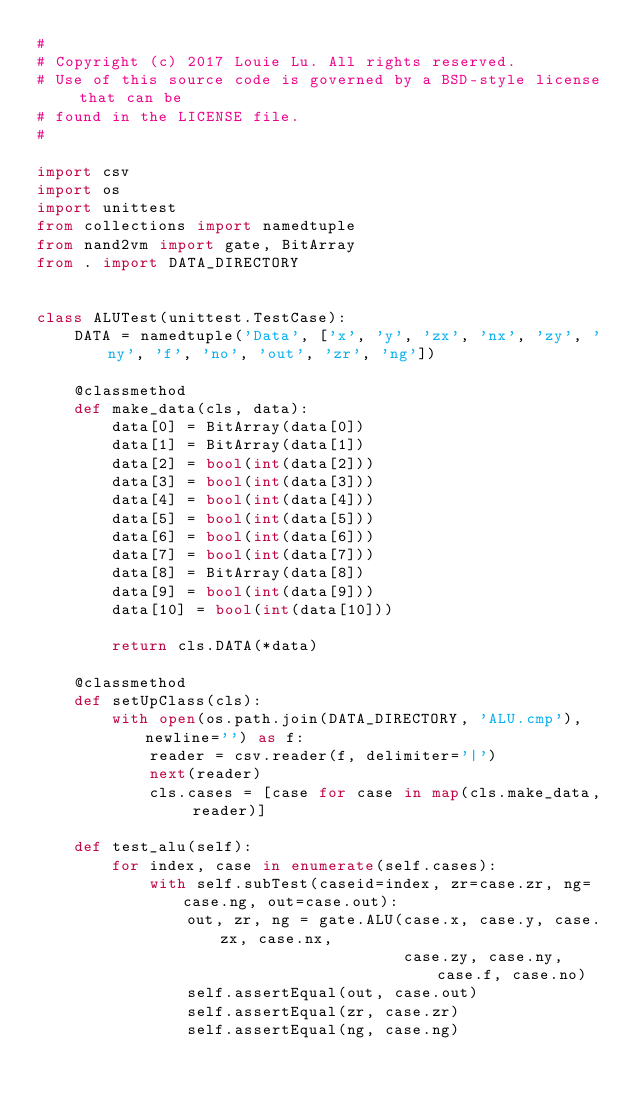<code> <loc_0><loc_0><loc_500><loc_500><_Python_>#
# Copyright (c) 2017 Louie Lu. All rights reserved.
# Use of this source code is governed by a BSD-style license that can be
# found in the LICENSE file.
#

import csv
import os
import unittest
from collections import namedtuple
from nand2vm import gate, BitArray
from . import DATA_DIRECTORY


class ALUTest(unittest.TestCase):
    DATA = namedtuple('Data', ['x', 'y', 'zx', 'nx', 'zy', 'ny', 'f', 'no', 'out', 'zr', 'ng'])

    @classmethod
    def make_data(cls, data):
        data[0] = BitArray(data[0])
        data[1] = BitArray(data[1])
        data[2] = bool(int(data[2]))
        data[3] = bool(int(data[3]))
        data[4] = bool(int(data[4]))
        data[5] = bool(int(data[5]))
        data[6] = bool(int(data[6]))
        data[7] = bool(int(data[7]))
        data[8] = BitArray(data[8])
        data[9] = bool(int(data[9]))
        data[10] = bool(int(data[10]))

        return cls.DATA(*data)

    @classmethod
    def setUpClass(cls):
        with open(os.path.join(DATA_DIRECTORY, 'ALU.cmp'), newline='') as f:
            reader = csv.reader(f, delimiter='|')
            next(reader)
            cls.cases = [case for case in map(cls.make_data, reader)]

    def test_alu(self):
        for index, case in enumerate(self.cases):
            with self.subTest(caseid=index, zr=case.zr, ng=case.ng, out=case.out):
                out, zr, ng = gate.ALU(case.x, case.y, case.zx, case.nx,
                                       case.zy, case.ny, case.f, case.no)
                self.assertEqual(out, case.out)
                self.assertEqual(zr, case.zr)
                self.assertEqual(ng, case.ng)
</code> 